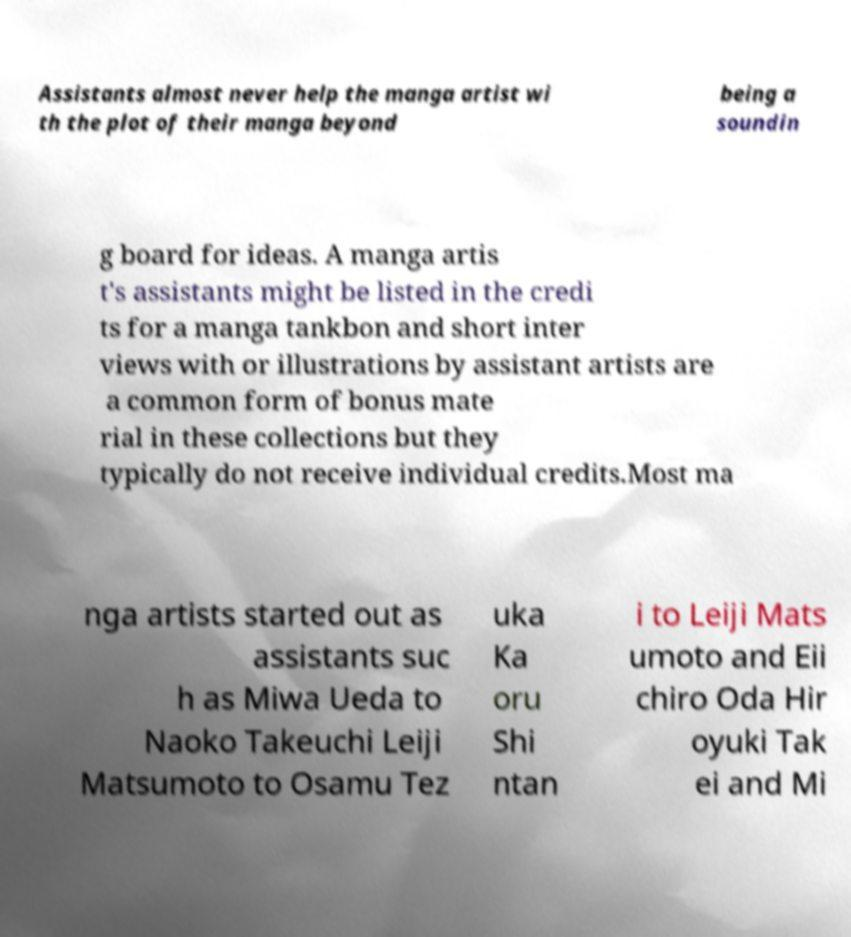Please identify and transcribe the text found in this image. Assistants almost never help the manga artist wi th the plot of their manga beyond being a soundin g board for ideas. A manga artis t's assistants might be listed in the credi ts for a manga tankbon and short inter views with or illustrations by assistant artists are a common form of bonus mate rial in these collections but they typically do not receive individual credits.Most ma nga artists started out as assistants suc h as Miwa Ueda to Naoko Takeuchi Leiji Matsumoto to Osamu Tez uka Ka oru Shi ntan i to Leiji Mats umoto and Eii chiro Oda Hir oyuki Tak ei and Mi 